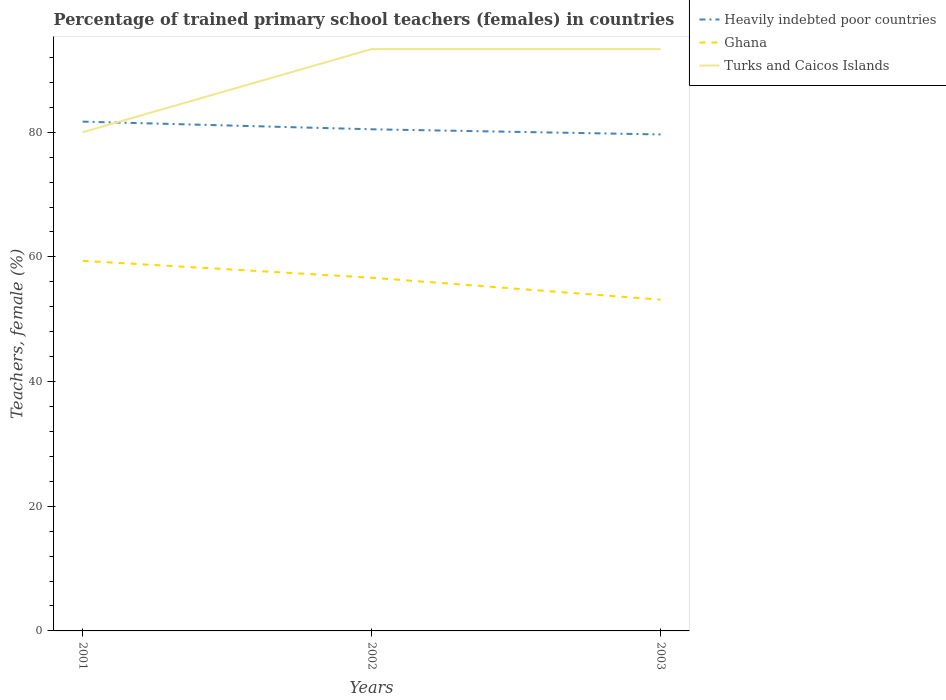Does the line corresponding to Turks and Caicos Islands intersect with the line corresponding to Heavily indebted poor countries?
Your answer should be very brief. Yes. Across all years, what is the maximum percentage of trained primary school teachers (females) in Ghana?
Your response must be concise. 53.13. In which year was the percentage of trained primary school teachers (females) in Heavily indebted poor countries maximum?
Offer a very short reply. 2003. What is the total percentage of trained primary school teachers (females) in Ghana in the graph?
Keep it short and to the point. 2.71. What is the difference between the highest and the second highest percentage of trained primary school teachers (females) in Turks and Caicos Islands?
Offer a very short reply. 13.33. How many lines are there?
Your answer should be compact. 3. How many years are there in the graph?
Offer a very short reply. 3. What is the difference between two consecutive major ticks on the Y-axis?
Offer a very short reply. 20. Are the values on the major ticks of Y-axis written in scientific E-notation?
Give a very brief answer. No. Where does the legend appear in the graph?
Ensure brevity in your answer.  Top right. How are the legend labels stacked?
Make the answer very short. Vertical. What is the title of the graph?
Your answer should be compact. Percentage of trained primary school teachers (females) in countries. Does "Fiji" appear as one of the legend labels in the graph?
Keep it short and to the point. No. What is the label or title of the Y-axis?
Make the answer very short. Teachers, female (%). What is the Teachers, female (%) of Heavily indebted poor countries in 2001?
Your answer should be very brief. 81.7. What is the Teachers, female (%) of Ghana in 2001?
Ensure brevity in your answer.  59.37. What is the Teachers, female (%) of Turks and Caicos Islands in 2001?
Your response must be concise. 80. What is the Teachers, female (%) in Heavily indebted poor countries in 2002?
Offer a terse response. 80.47. What is the Teachers, female (%) in Ghana in 2002?
Offer a very short reply. 56.66. What is the Teachers, female (%) in Turks and Caicos Islands in 2002?
Make the answer very short. 93.33. What is the Teachers, female (%) of Heavily indebted poor countries in 2003?
Ensure brevity in your answer.  79.64. What is the Teachers, female (%) in Ghana in 2003?
Make the answer very short. 53.13. What is the Teachers, female (%) in Turks and Caicos Islands in 2003?
Keep it short and to the point. 93.33. Across all years, what is the maximum Teachers, female (%) in Heavily indebted poor countries?
Your answer should be compact. 81.7. Across all years, what is the maximum Teachers, female (%) of Ghana?
Offer a very short reply. 59.37. Across all years, what is the maximum Teachers, female (%) in Turks and Caicos Islands?
Offer a terse response. 93.33. Across all years, what is the minimum Teachers, female (%) in Heavily indebted poor countries?
Ensure brevity in your answer.  79.64. Across all years, what is the minimum Teachers, female (%) in Ghana?
Give a very brief answer. 53.13. What is the total Teachers, female (%) of Heavily indebted poor countries in the graph?
Make the answer very short. 241.82. What is the total Teachers, female (%) of Ghana in the graph?
Your response must be concise. 169.17. What is the total Teachers, female (%) of Turks and Caicos Islands in the graph?
Keep it short and to the point. 266.67. What is the difference between the Teachers, female (%) of Heavily indebted poor countries in 2001 and that in 2002?
Provide a succinct answer. 1.23. What is the difference between the Teachers, female (%) in Ghana in 2001 and that in 2002?
Your answer should be very brief. 2.71. What is the difference between the Teachers, female (%) in Turks and Caicos Islands in 2001 and that in 2002?
Your response must be concise. -13.33. What is the difference between the Teachers, female (%) in Heavily indebted poor countries in 2001 and that in 2003?
Your answer should be very brief. 2.06. What is the difference between the Teachers, female (%) of Ghana in 2001 and that in 2003?
Your response must be concise. 6.24. What is the difference between the Teachers, female (%) in Turks and Caicos Islands in 2001 and that in 2003?
Your answer should be compact. -13.33. What is the difference between the Teachers, female (%) in Heavily indebted poor countries in 2002 and that in 2003?
Offer a very short reply. 0.83. What is the difference between the Teachers, female (%) in Ghana in 2002 and that in 2003?
Ensure brevity in your answer.  3.53. What is the difference between the Teachers, female (%) in Heavily indebted poor countries in 2001 and the Teachers, female (%) in Ghana in 2002?
Ensure brevity in your answer.  25.04. What is the difference between the Teachers, female (%) of Heavily indebted poor countries in 2001 and the Teachers, female (%) of Turks and Caicos Islands in 2002?
Your response must be concise. -11.63. What is the difference between the Teachers, female (%) of Ghana in 2001 and the Teachers, female (%) of Turks and Caicos Islands in 2002?
Your response must be concise. -33.96. What is the difference between the Teachers, female (%) of Heavily indebted poor countries in 2001 and the Teachers, female (%) of Ghana in 2003?
Your response must be concise. 28.57. What is the difference between the Teachers, female (%) in Heavily indebted poor countries in 2001 and the Teachers, female (%) in Turks and Caicos Islands in 2003?
Give a very brief answer. -11.63. What is the difference between the Teachers, female (%) of Ghana in 2001 and the Teachers, female (%) of Turks and Caicos Islands in 2003?
Give a very brief answer. -33.96. What is the difference between the Teachers, female (%) in Heavily indebted poor countries in 2002 and the Teachers, female (%) in Ghana in 2003?
Make the answer very short. 27.34. What is the difference between the Teachers, female (%) in Heavily indebted poor countries in 2002 and the Teachers, female (%) in Turks and Caicos Islands in 2003?
Keep it short and to the point. -12.86. What is the difference between the Teachers, female (%) in Ghana in 2002 and the Teachers, female (%) in Turks and Caicos Islands in 2003?
Make the answer very short. -36.67. What is the average Teachers, female (%) in Heavily indebted poor countries per year?
Make the answer very short. 80.61. What is the average Teachers, female (%) of Ghana per year?
Your answer should be very brief. 56.39. What is the average Teachers, female (%) of Turks and Caicos Islands per year?
Your answer should be very brief. 88.89. In the year 2001, what is the difference between the Teachers, female (%) in Heavily indebted poor countries and Teachers, female (%) in Ghana?
Your answer should be very brief. 22.33. In the year 2001, what is the difference between the Teachers, female (%) in Heavily indebted poor countries and Teachers, female (%) in Turks and Caicos Islands?
Keep it short and to the point. 1.7. In the year 2001, what is the difference between the Teachers, female (%) in Ghana and Teachers, female (%) in Turks and Caicos Islands?
Provide a succinct answer. -20.63. In the year 2002, what is the difference between the Teachers, female (%) in Heavily indebted poor countries and Teachers, female (%) in Ghana?
Keep it short and to the point. 23.81. In the year 2002, what is the difference between the Teachers, female (%) in Heavily indebted poor countries and Teachers, female (%) in Turks and Caicos Islands?
Your answer should be very brief. -12.86. In the year 2002, what is the difference between the Teachers, female (%) in Ghana and Teachers, female (%) in Turks and Caicos Islands?
Offer a terse response. -36.67. In the year 2003, what is the difference between the Teachers, female (%) of Heavily indebted poor countries and Teachers, female (%) of Ghana?
Your response must be concise. 26.51. In the year 2003, what is the difference between the Teachers, female (%) in Heavily indebted poor countries and Teachers, female (%) in Turks and Caicos Islands?
Provide a short and direct response. -13.69. In the year 2003, what is the difference between the Teachers, female (%) of Ghana and Teachers, female (%) of Turks and Caicos Islands?
Your answer should be compact. -40.2. What is the ratio of the Teachers, female (%) of Heavily indebted poor countries in 2001 to that in 2002?
Offer a terse response. 1.02. What is the ratio of the Teachers, female (%) in Ghana in 2001 to that in 2002?
Provide a succinct answer. 1.05. What is the ratio of the Teachers, female (%) in Turks and Caicos Islands in 2001 to that in 2002?
Offer a very short reply. 0.86. What is the ratio of the Teachers, female (%) of Heavily indebted poor countries in 2001 to that in 2003?
Offer a very short reply. 1.03. What is the ratio of the Teachers, female (%) in Ghana in 2001 to that in 2003?
Your answer should be very brief. 1.12. What is the ratio of the Teachers, female (%) in Turks and Caicos Islands in 2001 to that in 2003?
Your response must be concise. 0.86. What is the ratio of the Teachers, female (%) of Heavily indebted poor countries in 2002 to that in 2003?
Ensure brevity in your answer.  1.01. What is the ratio of the Teachers, female (%) in Ghana in 2002 to that in 2003?
Offer a terse response. 1.07. What is the difference between the highest and the second highest Teachers, female (%) in Heavily indebted poor countries?
Give a very brief answer. 1.23. What is the difference between the highest and the second highest Teachers, female (%) of Ghana?
Keep it short and to the point. 2.71. What is the difference between the highest and the second highest Teachers, female (%) in Turks and Caicos Islands?
Keep it short and to the point. 0. What is the difference between the highest and the lowest Teachers, female (%) of Heavily indebted poor countries?
Your response must be concise. 2.06. What is the difference between the highest and the lowest Teachers, female (%) of Ghana?
Offer a very short reply. 6.24. What is the difference between the highest and the lowest Teachers, female (%) in Turks and Caicos Islands?
Give a very brief answer. 13.33. 